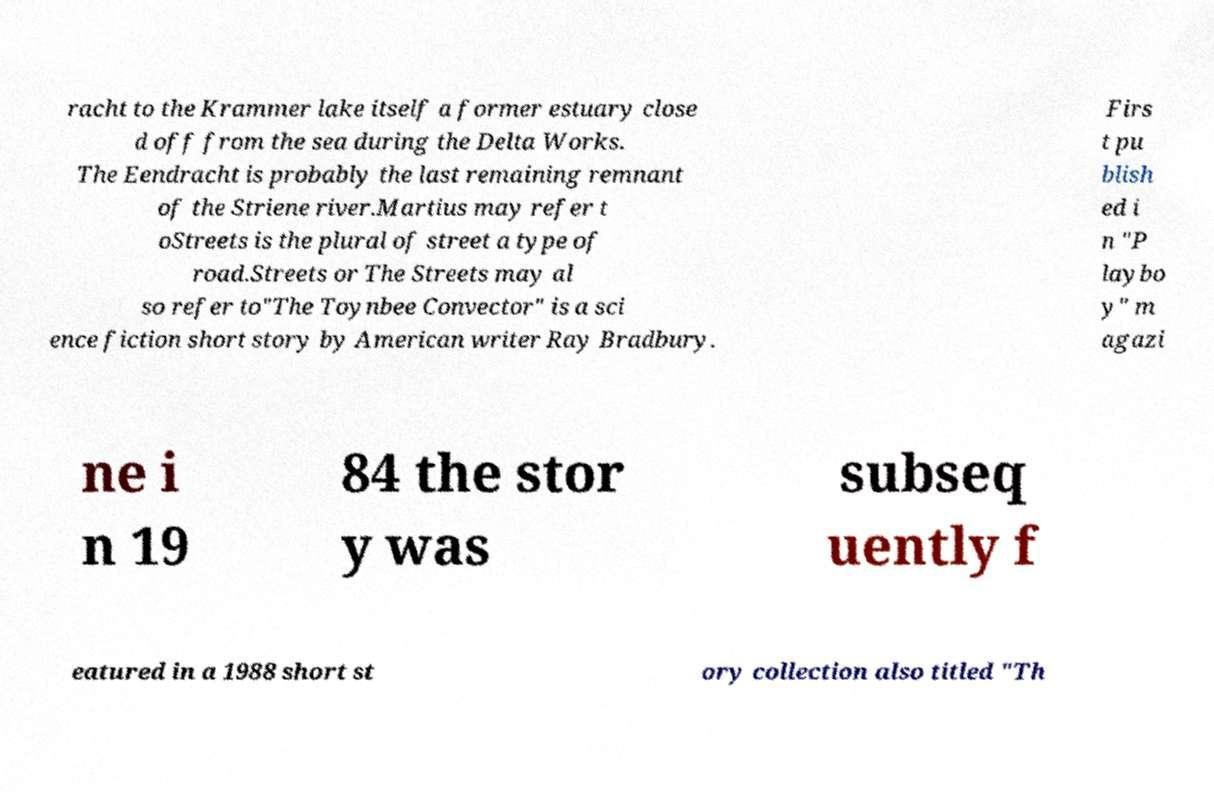Could you assist in decoding the text presented in this image and type it out clearly? racht to the Krammer lake itself a former estuary close d off from the sea during the Delta Works. The Eendracht is probably the last remaining remnant of the Striene river.Martius may refer t oStreets is the plural of street a type of road.Streets or The Streets may al so refer to"The Toynbee Convector" is a sci ence fiction short story by American writer Ray Bradbury. Firs t pu blish ed i n "P laybo y" m agazi ne i n 19 84 the stor y was subseq uently f eatured in a 1988 short st ory collection also titled "Th 